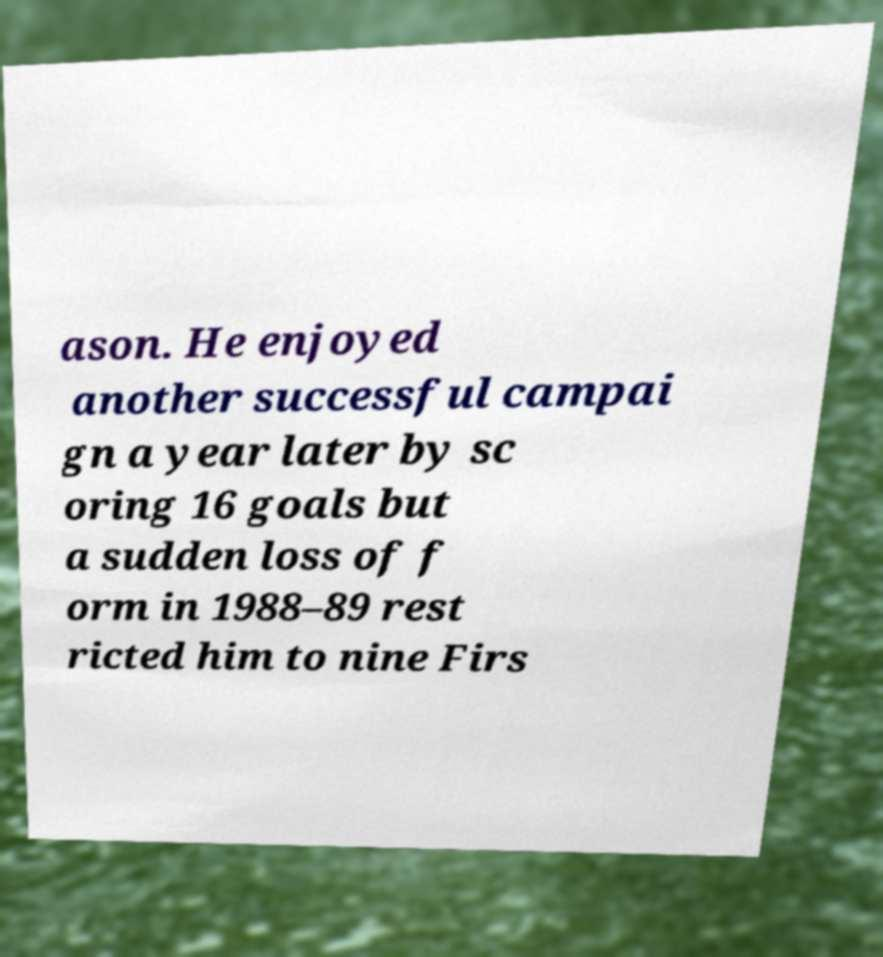I need the written content from this picture converted into text. Can you do that? ason. He enjoyed another successful campai gn a year later by sc oring 16 goals but a sudden loss of f orm in 1988–89 rest ricted him to nine Firs 